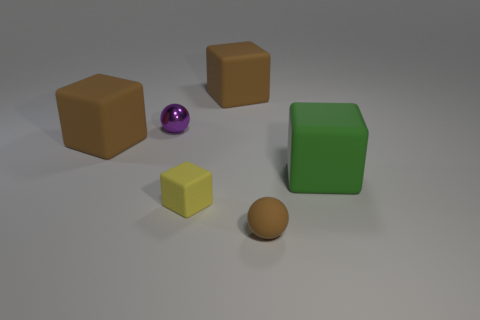Are there any objects that are behind the object that is right of the brown matte ball?
Ensure brevity in your answer.  Yes. What material is the green object that is the same shape as the small yellow matte thing?
Your response must be concise. Rubber. There is a sphere behind the big green block; how many big brown rubber cubes are in front of it?
Give a very brief answer. 1. Is there any other thing that is the same color as the small metal object?
Make the answer very short. No. How many objects are small yellow matte things or big things to the left of the tiny brown rubber sphere?
Provide a succinct answer. 3. There is a tiny thing to the left of the rubber cube that is in front of the large matte thing that is on the right side of the tiny brown rubber ball; what is its material?
Provide a short and direct response. Metal. What is the size of the ball that is the same material as the green cube?
Your response must be concise. Small. There is a sphere to the right of the cube in front of the green block; what color is it?
Provide a succinct answer. Brown. How many big brown things have the same material as the brown sphere?
Provide a succinct answer. 2. How many matte objects are either big green things or tiny purple things?
Your response must be concise. 1. 